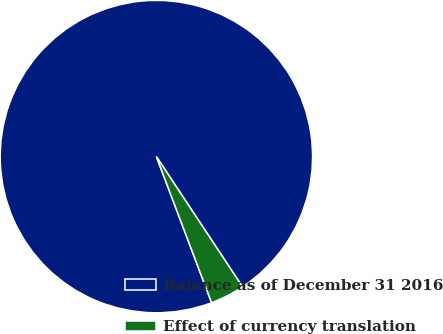Convert chart to OTSL. <chart><loc_0><loc_0><loc_500><loc_500><pie_chart><fcel>Balance as of December 31 2016<fcel>Effect of currency translation<nl><fcel>96.45%<fcel>3.55%<nl></chart> 